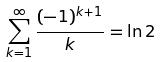<formula> <loc_0><loc_0><loc_500><loc_500>\sum _ { k = 1 } ^ { \infty } \frac { ( - 1 ) ^ { k + 1 } } { k } = \ln 2</formula> 